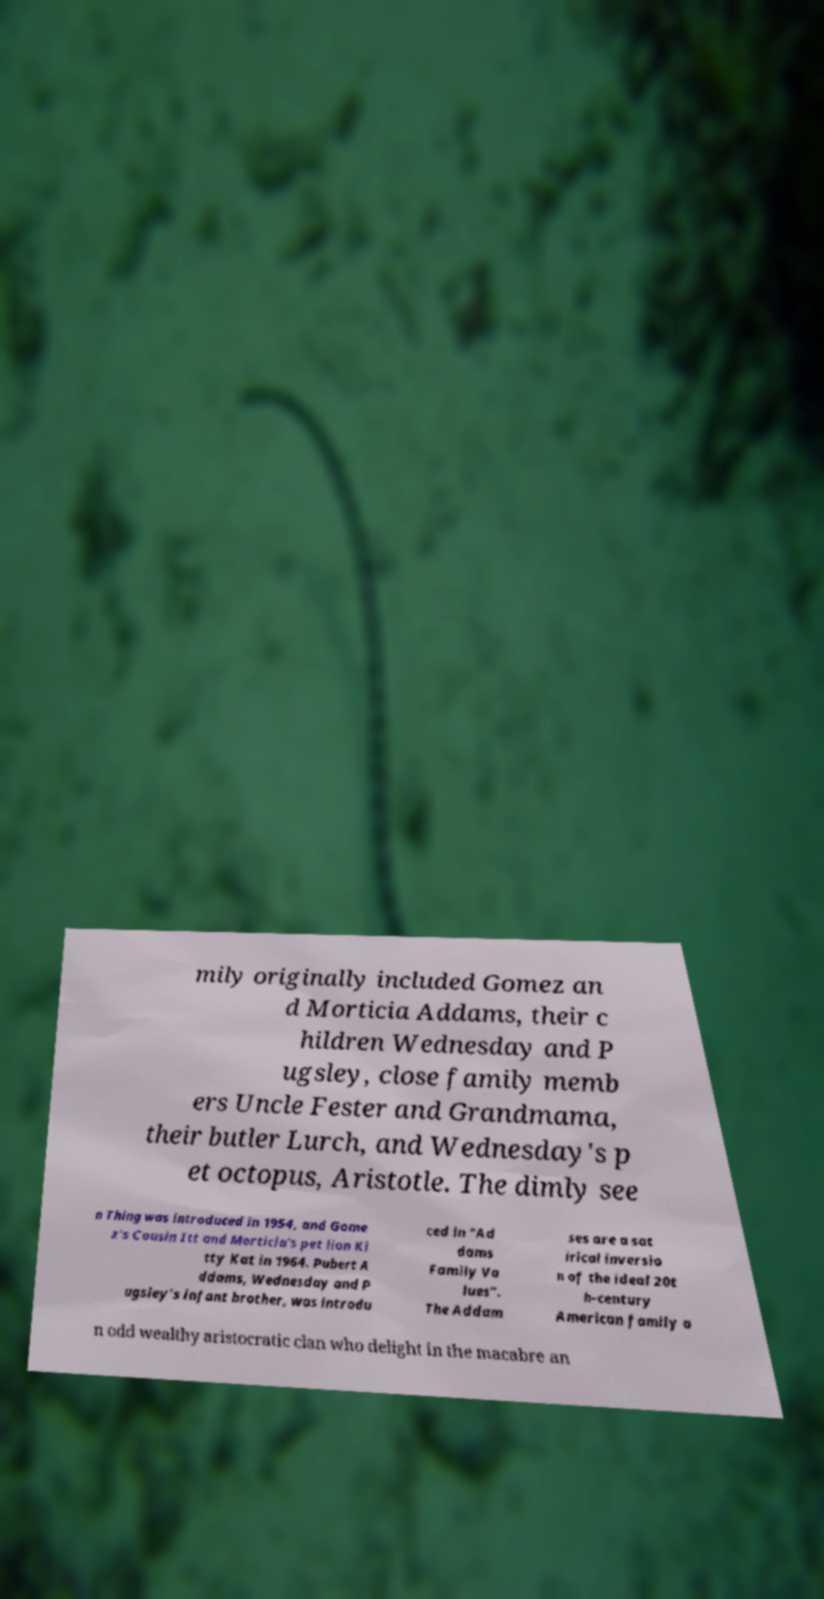For documentation purposes, I need the text within this image transcribed. Could you provide that? mily originally included Gomez an d Morticia Addams, their c hildren Wednesday and P ugsley, close family memb ers Uncle Fester and Grandmama, their butler Lurch, and Wednesday's p et octopus, Aristotle. The dimly see n Thing was introduced in 1954, and Gome z's Cousin Itt and Morticia's pet lion Ki tty Kat in 1964. Pubert A ddams, Wednesday and P ugsley’s infant brother, was introdu ced in "Ad dams Family Va lues". The Addam ses are a sat irical inversio n of the ideal 20t h-century American family a n odd wealthy aristocratic clan who delight in the macabre an 